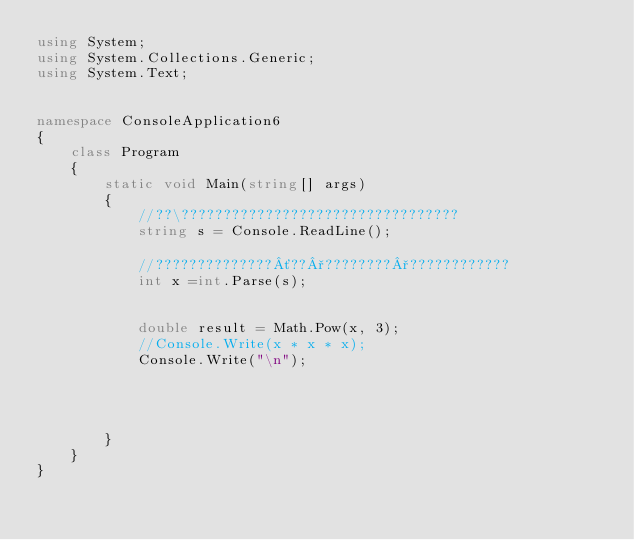Convert code to text. <code><loc_0><loc_0><loc_500><loc_500><_C#_>using System;
using System.Collections.Generic;
using System.Text;


namespace ConsoleApplication6
{
    class Program
    {
        static void Main(string[] args)
        {
            //??\?????????????????????????????????
            string s = Console.ReadLine();

            //??????????????´??°????????°????????????
            int x =int.Parse(s);


            double result = Math.Pow(x, 3); 
            //Console.Write(x * x * x);
            Console.Write("\n");

                 
       
           
        }
    }
}</code> 